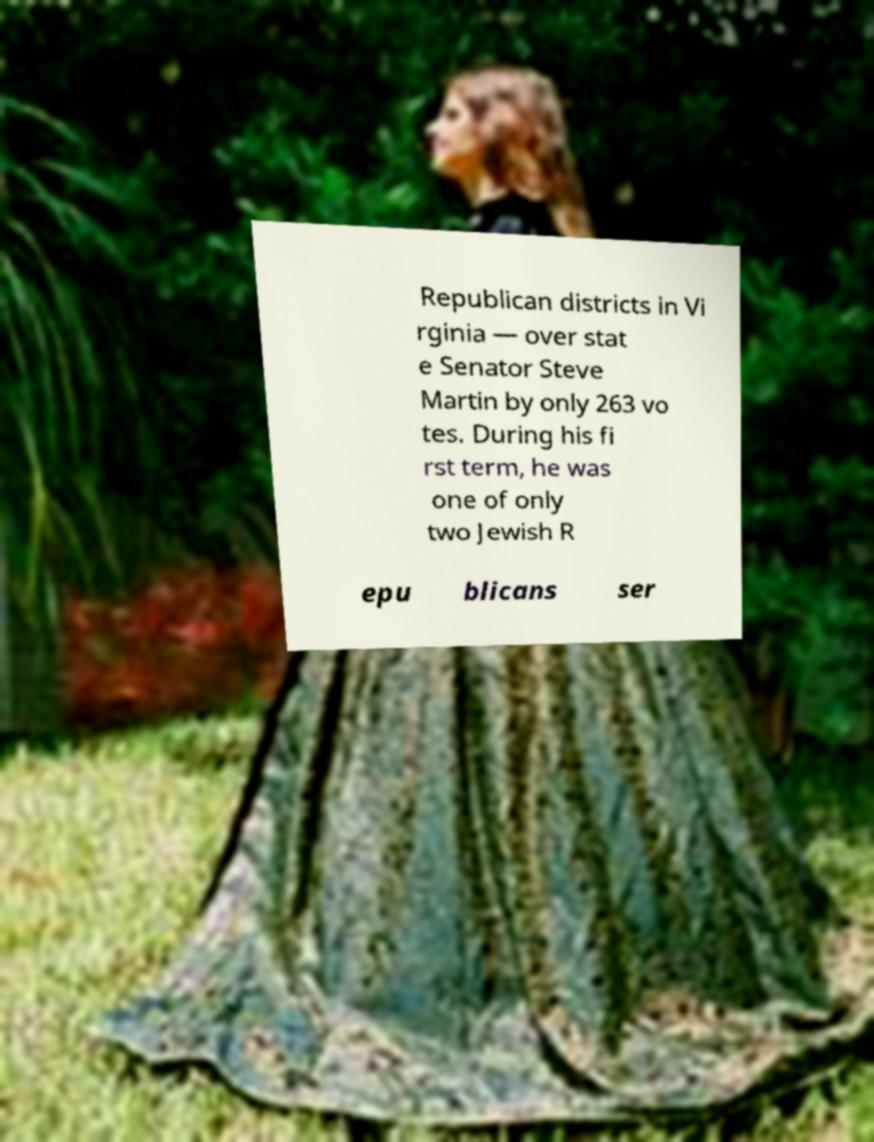Can you accurately transcribe the text from the provided image for me? Republican districts in Vi rginia — over stat e Senator Steve Martin by only 263 vo tes. During his fi rst term, he was one of only two Jewish R epu blicans ser 